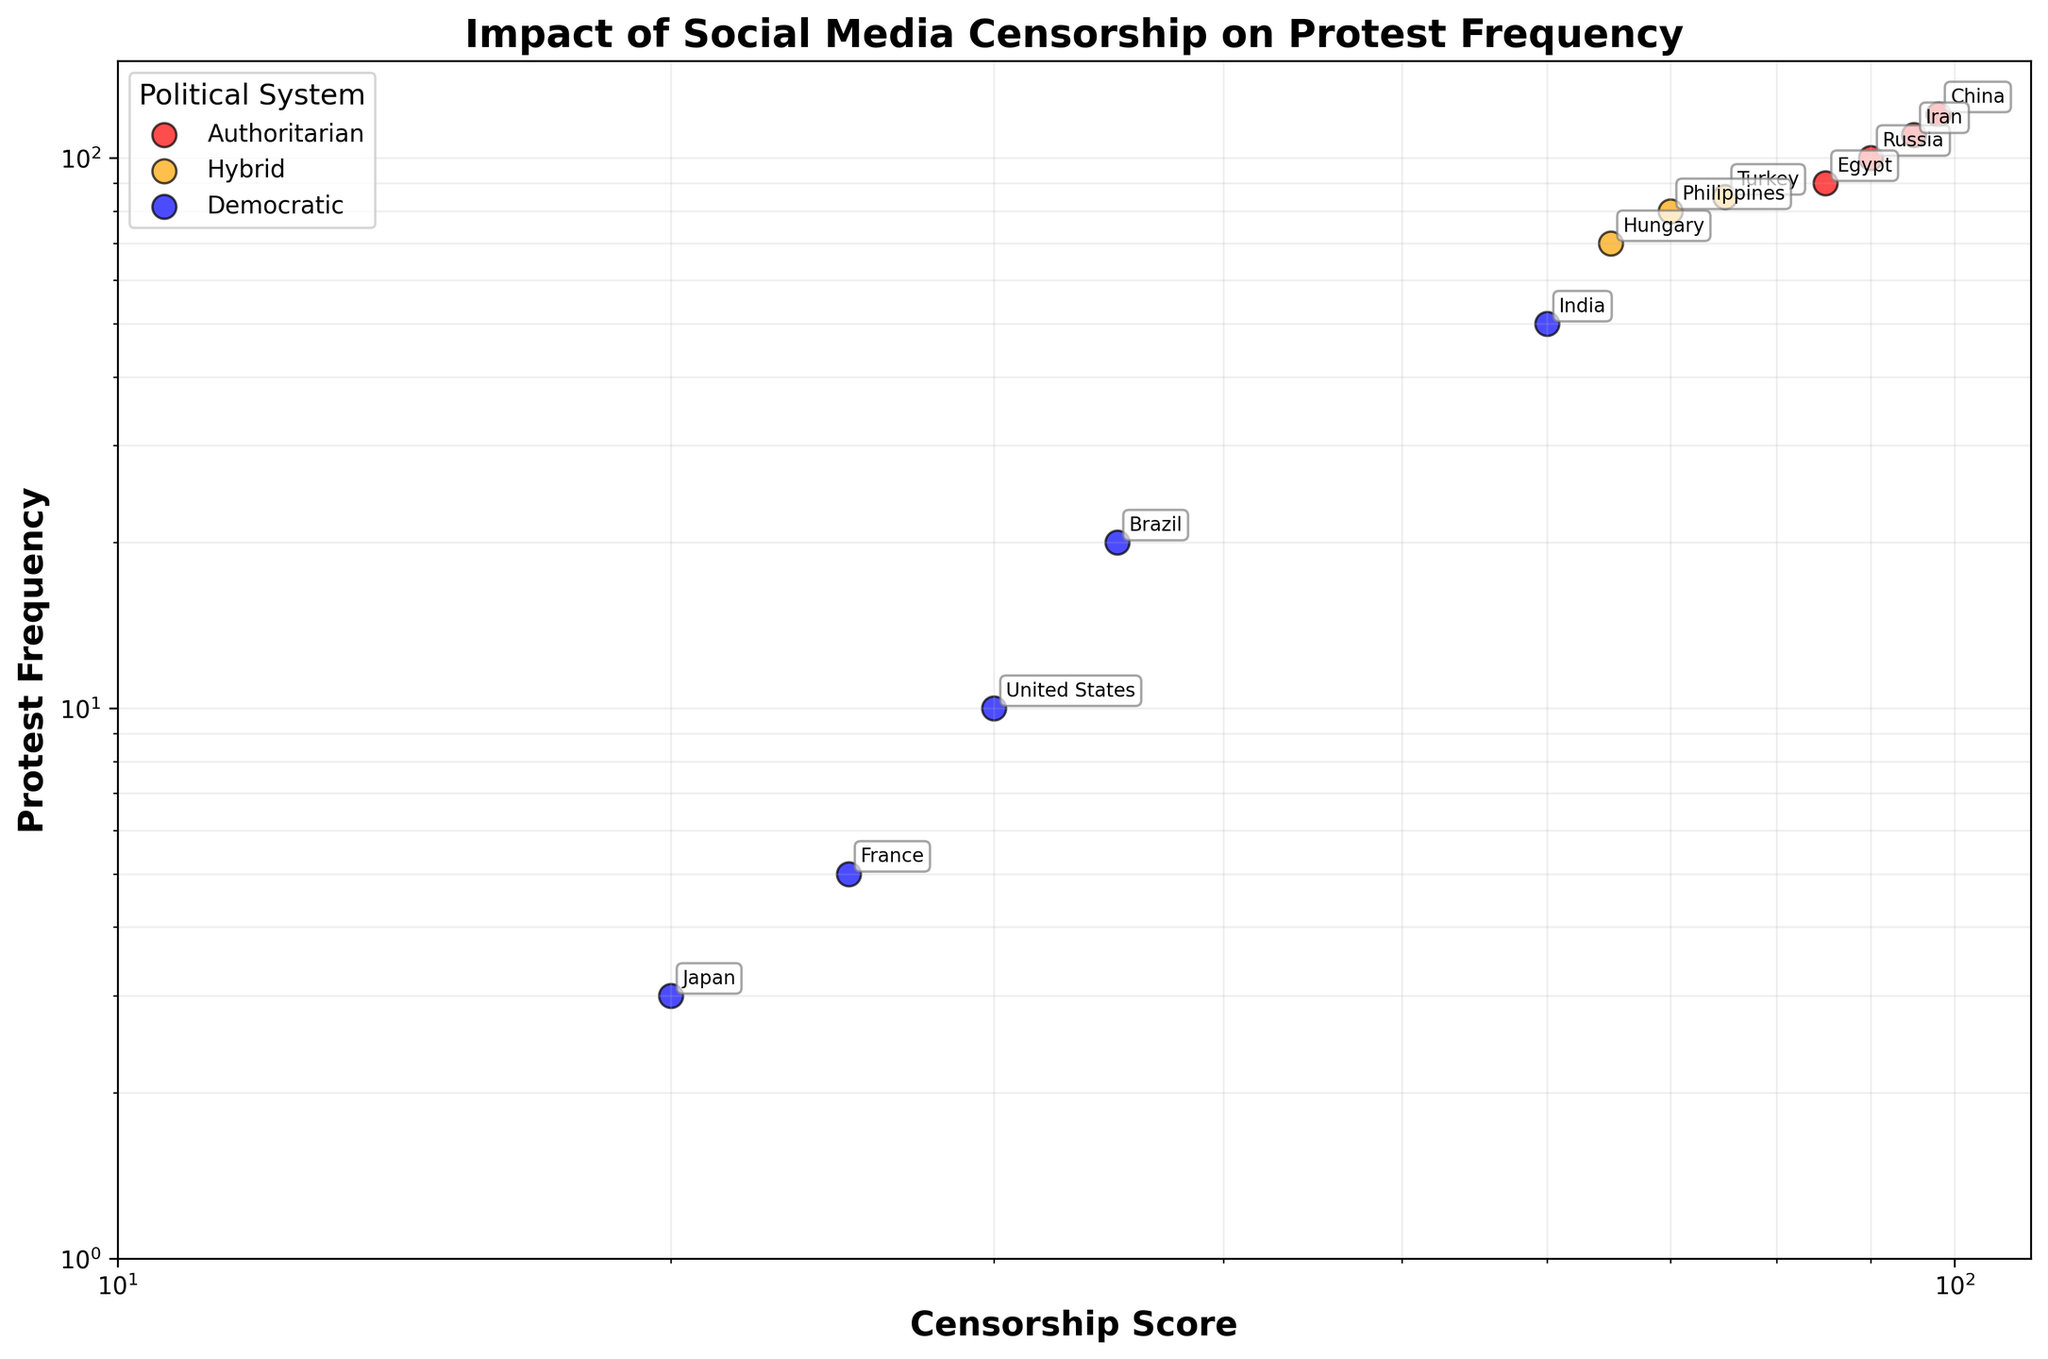How many data points represent authoritarian regimes? By inspecting the legend and identifying the color representing 'Authoritarian' regimes (red), we can count the number of red scatter points in the plot (China, Russia, Iran, and Egypt).
Answer: 4 What is the Censorship Score and Protest Frequency for India? India is labeled on the scatter plot. We locate "India" and read the coordinates corresponding to the Censorship Score (x-axis) and Protest Frequency (y-axis).
Answer: Censorship Score: 60, Protest Frequency: 50 Which political system has the highest Protest Frequency, and which country does it belong to? Authoritarian regimes have the highest Protest Frequency. Among them, the country with the highest frequency is China. We identify the point for China on the plot.
Answer: Authoritarian, China Compare the Protest Frequency of democratic regimes with a Censorship Score below 50. Which country has the highest frequency? Identify countries in democratic regimes with a Censorship Score below 50 (Brazil, France, and Japan). Compare their Protest Frequencies, locating the highest one.
Answer: Brazil Is there a general trend between Censorship Score and Protest Frequency? By observing the overall direction of scatter points on the log-log scale, it can be determined whether there’s an increasing or decreasing trend. An increasing trend suggests higher censorship corresponds to higher protest frequencies.
Answer: Increasing trend How does Protest Frequency in Hybrid regimes compare to Democratic regimes? Inspect points associated with 'Hybrid' and 'Democratic'. Generally, hybrid regimes (Turkey, Hungary, Philippines) show higher protest frequencies than democratic regimes (United States, Brazil, France, Japan).
Answer: Generally higher in Hybrid regimes Identify the country with the lowest Censorship Score and state its Protest Frequency. Locate the leftmost data point on the scatter plot, which corresponds to Japan, and read its Protest Frequency.
Answer: Japan, Protest Frequency: 3 What is the range of Protest Frequencies for Authoritarian regimes? Check the y-axis values for the authoritarian regime points, identifying the minimum and maximum protest frequencies (Egypt: 90 to China: 120).
Answer: 90-120 Which country has a Censorship Score of approximately 85 and what is its Protest Frequency? Locate the data point closest to 85 on the x-axis and read the corresponding y-axis value. The country is Egypt.
Answer: Egypt, Protest Frequency: 90 What is the average Censorship Score of the hybrid regimes represented in the plot? Identify 'Hybrid' regime countries (Turkey, Hungary, Philippines), sum their Censorship Scores (75, 65, 70), and divide by the number of countries.
Answer: (75 + 65 + 70) / 3 = 70 